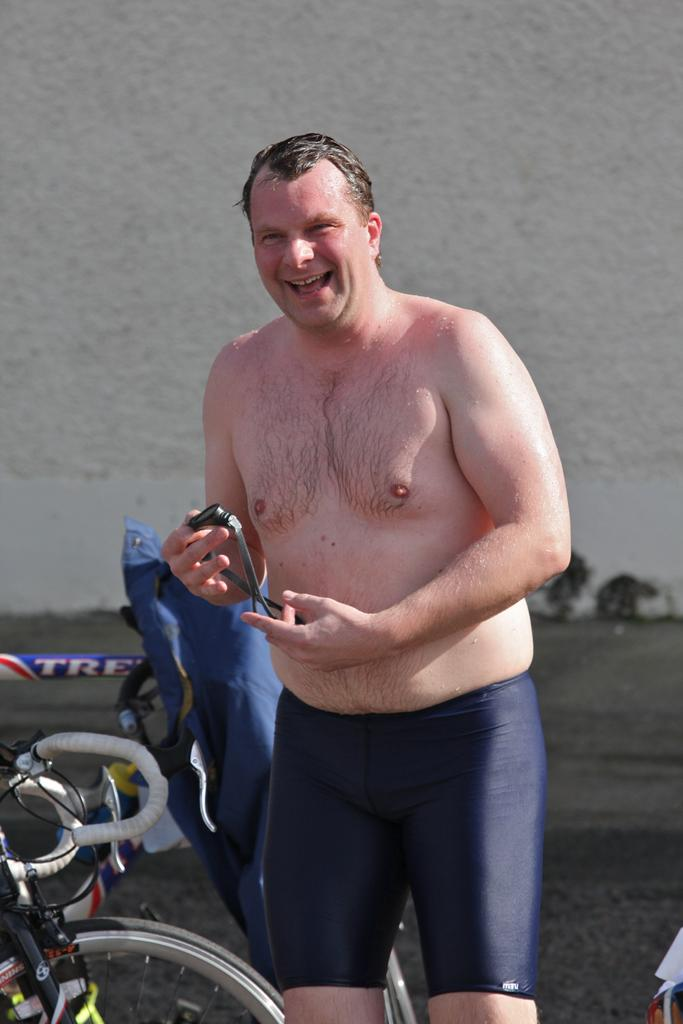What is the main subject of the image? There is a man standing in the image. What is the man holding in his hand? The man is holding something in his hand. Can you describe the background of the image? There are other things visible in the background of the image. What type of question is the beast asking in the image? There is no beast or question present in the image. What kind of apparatus is being used by the man in the image? The provided facts do not specify what the man is holding in his hand, so it cannot be determined if it is an apparatus. 